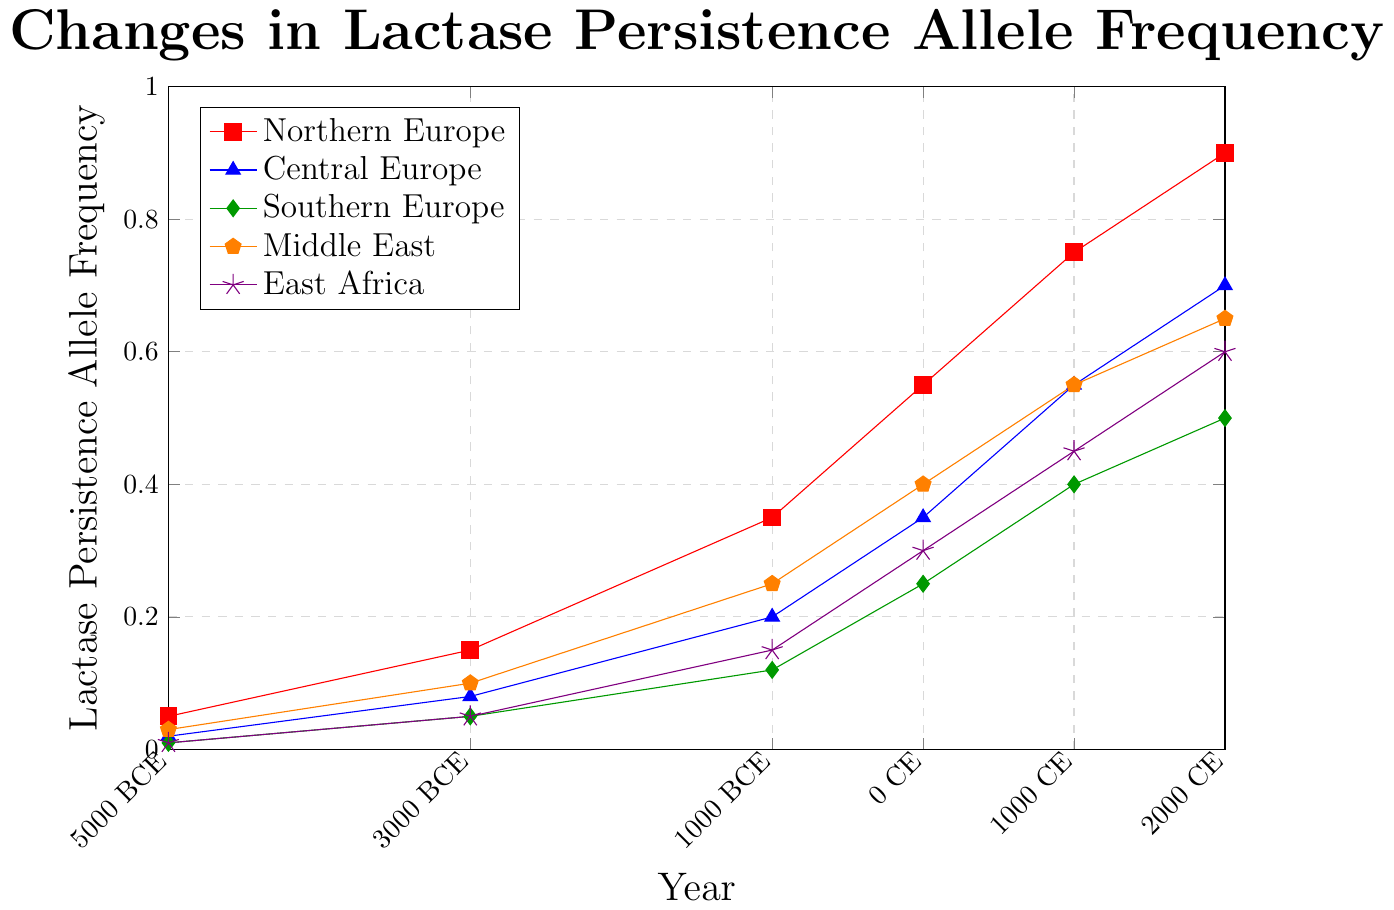what is the initial allele frequency for Northern Europe in 5000 BCE? The initial allele frequency for Northern Europe in 5000 BCE is directly given in the dataset and represented in the figure by the first point in the red line corresponding to Northern Europe.
Answer: 0.05 How did the lactase persistence allele frequency change in Northern Europe from 5000 BCE to 2000 CE? To find the change, look at the start and end frequencies for Northern Europe. It started at 0.05 in 5000 BCE and increased to 0.90 in 2000 CE. Subtraction of these values gives the change: 0.90 - 0.05 = 0.85.
Answer: 0.85 Which region shows the highest allele frequency of lactase persistence in 2000 CE? The allele frequencies for each region in 2000 CE can be identified by the data points at 2000 CE. Compare the heights of these points to determine which is the highest. Northern Europe's data point at 0.90 is the highest among all regions.
Answer: Northern Europe How does the rate of change in lactase persistence allele frequency compare between Central Europe and Southern Europe from 1000 CE to 2000 CE? Examine the slope of the lines from 1000 CE to 2000 CE. Central Europe's frequency changes from 0.55 to 0.70, a difference of 0.15 over this period. Southern Europe's frequency changes from 0.40 to 0.50, a difference of 0.10. Therefore, Central Europe's frequency increased more rapidly.
Answer: Central Europe What is the average lactase persistence allele frequency in Middle East over time? To find the average, sum the frequencies for the Middle East across all time periods and divide by the number of data points. Middle East frequencies: 0.03, 0.10, 0.25, 0.40, 0.55, 0.65. The sum is 1.98 and there are 6 data points, so the average is 1.98 / 6 = 0.33
Answer: 0.33 Which region had the smallest increase in lactase persistence allele frequency from 5000 BCE to 2000 CE? Calculate the differences for each region: 
Northern Europe: 0.90 - 0.05 = 0.85 
Central Europe: 0.70 - 0.02 = 0.68 
Southern Europe: 0.50 - 0.01 = 0.49 
Middle East: 0.65 - 0.03 = 0.62 
East Africa: 0.60 - 0.01 = 0.59 
The smallest increase is in Southern Europe.
Answer: Southern Europe In 0 CE, which regions had a lactase persistence allele frequency higher than 0.30? Look for the frequencies at 0 CE for each region. Northern Europe (0.55), Central Europe (0.35), Middle East (0.40), East Africa (0.30), Southern Europe (0.25). The regions with frequencies higher than 0.30 are Northern Europe, Central Europe, and Middle East.
Answer: Northern Europe, Central Europe, Middle East Is there any time period where the allele frequency is the same for two regions? By comparing the frequencies for each time period across different regions:
5000 BCE: (Northern Europe: 0.05, Central Europe: 0.02, Southern Europe: 0.01, Middle East: 0.03, East Africa: 0.01)
3000 BCE: (Northern Europe: 0.15, Central Europe: 0.08, Southern Europe: 0.05, Middle East: 0.10, East Africa: 0.05)
1000 BCE: (Northern Europe: 0.35, Central Europe: 0.20, Southern Europe: 0.12, Middle East: 0.25, East Africa: 0.15)
0 CE: (Northern Europe: 0.55, Central Europe: 0.35, Southern Europe: 0.25, Middle East: 0.40, East Africa: 0.30)
1000 CE: (Northern Europe: 0.75, Central Europe: 0.55, Southern Europe: 0.40, Middle East: 0.55, East Africa: 0.45)
2000 CE: (Northern Europe: 0.90, Central Europe: 0.70, Southern Europe: 0.50, Middle East: 0.65, East Africa: 0.60)
The frequencies for Central Europe and Middle East are both 0.55 in 1000 CE.
Answer: Yes, in 1000 CE for Central Europe and Middle East What is the total increase in allele frequency for East Africa from 1000 BCE to 2000 CE? Subtract the frequency in 1000 BCE from the frequency in 2000 CE: 0.60 - 0.15 = 0.45.
Answer: 0.45 